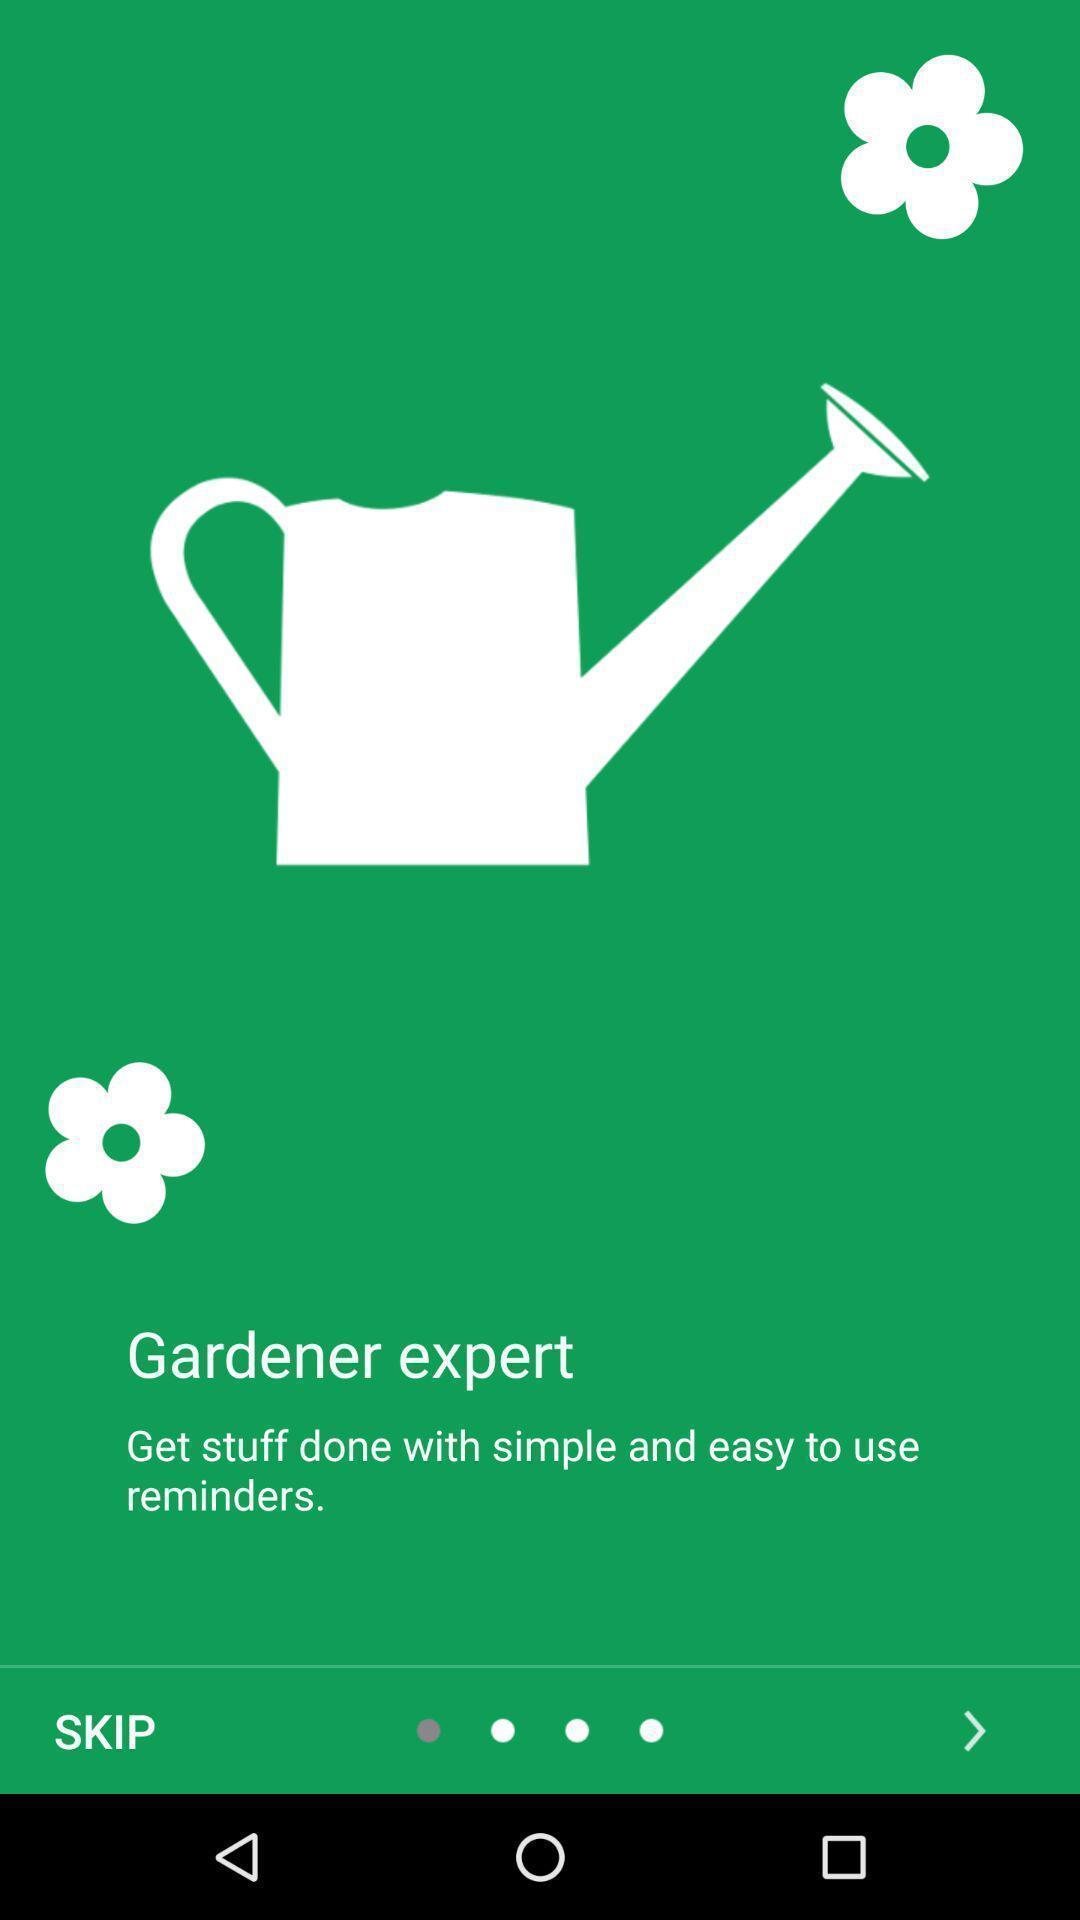Tell me what you see in this picture. Welcome page. 